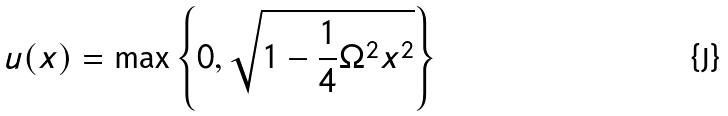Convert formula to latex. <formula><loc_0><loc_0><loc_500><loc_500>u ( x ) = \max \left \{ 0 , \sqrt { 1 - \frac { 1 } { 4 } \Omega ^ { 2 } x ^ { 2 } } \right \}</formula> 